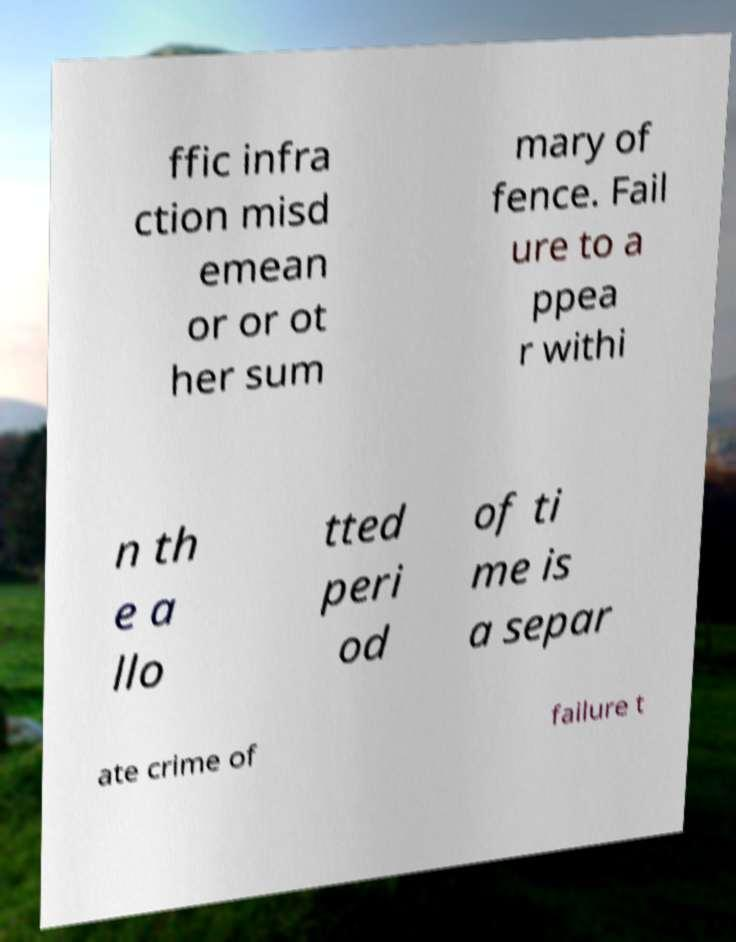For documentation purposes, I need the text within this image transcribed. Could you provide that? ffic infra ction misd emean or or ot her sum mary of fence. Fail ure to a ppea r withi n th e a llo tted peri od of ti me is a separ ate crime of failure t 